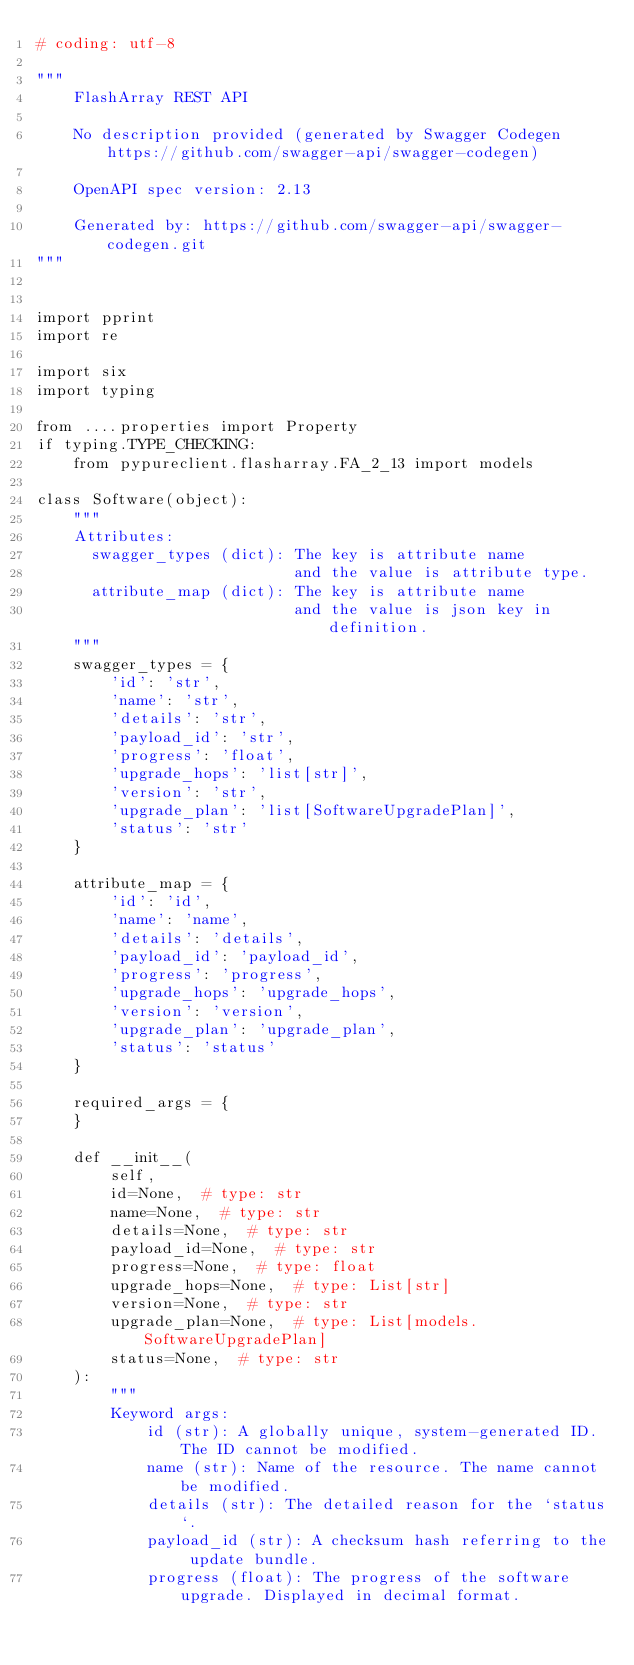Convert code to text. <code><loc_0><loc_0><loc_500><loc_500><_Python_># coding: utf-8

"""
    FlashArray REST API

    No description provided (generated by Swagger Codegen https://github.com/swagger-api/swagger-codegen)

    OpenAPI spec version: 2.13
    
    Generated by: https://github.com/swagger-api/swagger-codegen.git
"""


import pprint
import re

import six
import typing

from ....properties import Property
if typing.TYPE_CHECKING:
    from pypureclient.flasharray.FA_2_13 import models

class Software(object):
    """
    Attributes:
      swagger_types (dict): The key is attribute name
                            and the value is attribute type.
      attribute_map (dict): The key is attribute name
                            and the value is json key in definition.
    """
    swagger_types = {
        'id': 'str',
        'name': 'str',
        'details': 'str',
        'payload_id': 'str',
        'progress': 'float',
        'upgrade_hops': 'list[str]',
        'version': 'str',
        'upgrade_plan': 'list[SoftwareUpgradePlan]',
        'status': 'str'
    }

    attribute_map = {
        'id': 'id',
        'name': 'name',
        'details': 'details',
        'payload_id': 'payload_id',
        'progress': 'progress',
        'upgrade_hops': 'upgrade_hops',
        'version': 'version',
        'upgrade_plan': 'upgrade_plan',
        'status': 'status'
    }

    required_args = {
    }

    def __init__(
        self,
        id=None,  # type: str
        name=None,  # type: str
        details=None,  # type: str
        payload_id=None,  # type: str
        progress=None,  # type: float
        upgrade_hops=None,  # type: List[str]
        version=None,  # type: str
        upgrade_plan=None,  # type: List[models.SoftwareUpgradePlan]
        status=None,  # type: str
    ):
        """
        Keyword args:
            id (str): A globally unique, system-generated ID. The ID cannot be modified.
            name (str): Name of the resource. The name cannot be modified.
            details (str): The detailed reason for the `status`.
            payload_id (str): A checksum hash referring to the update bundle.
            progress (float): The progress of the software upgrade. Displayed in decimal format.</code> 